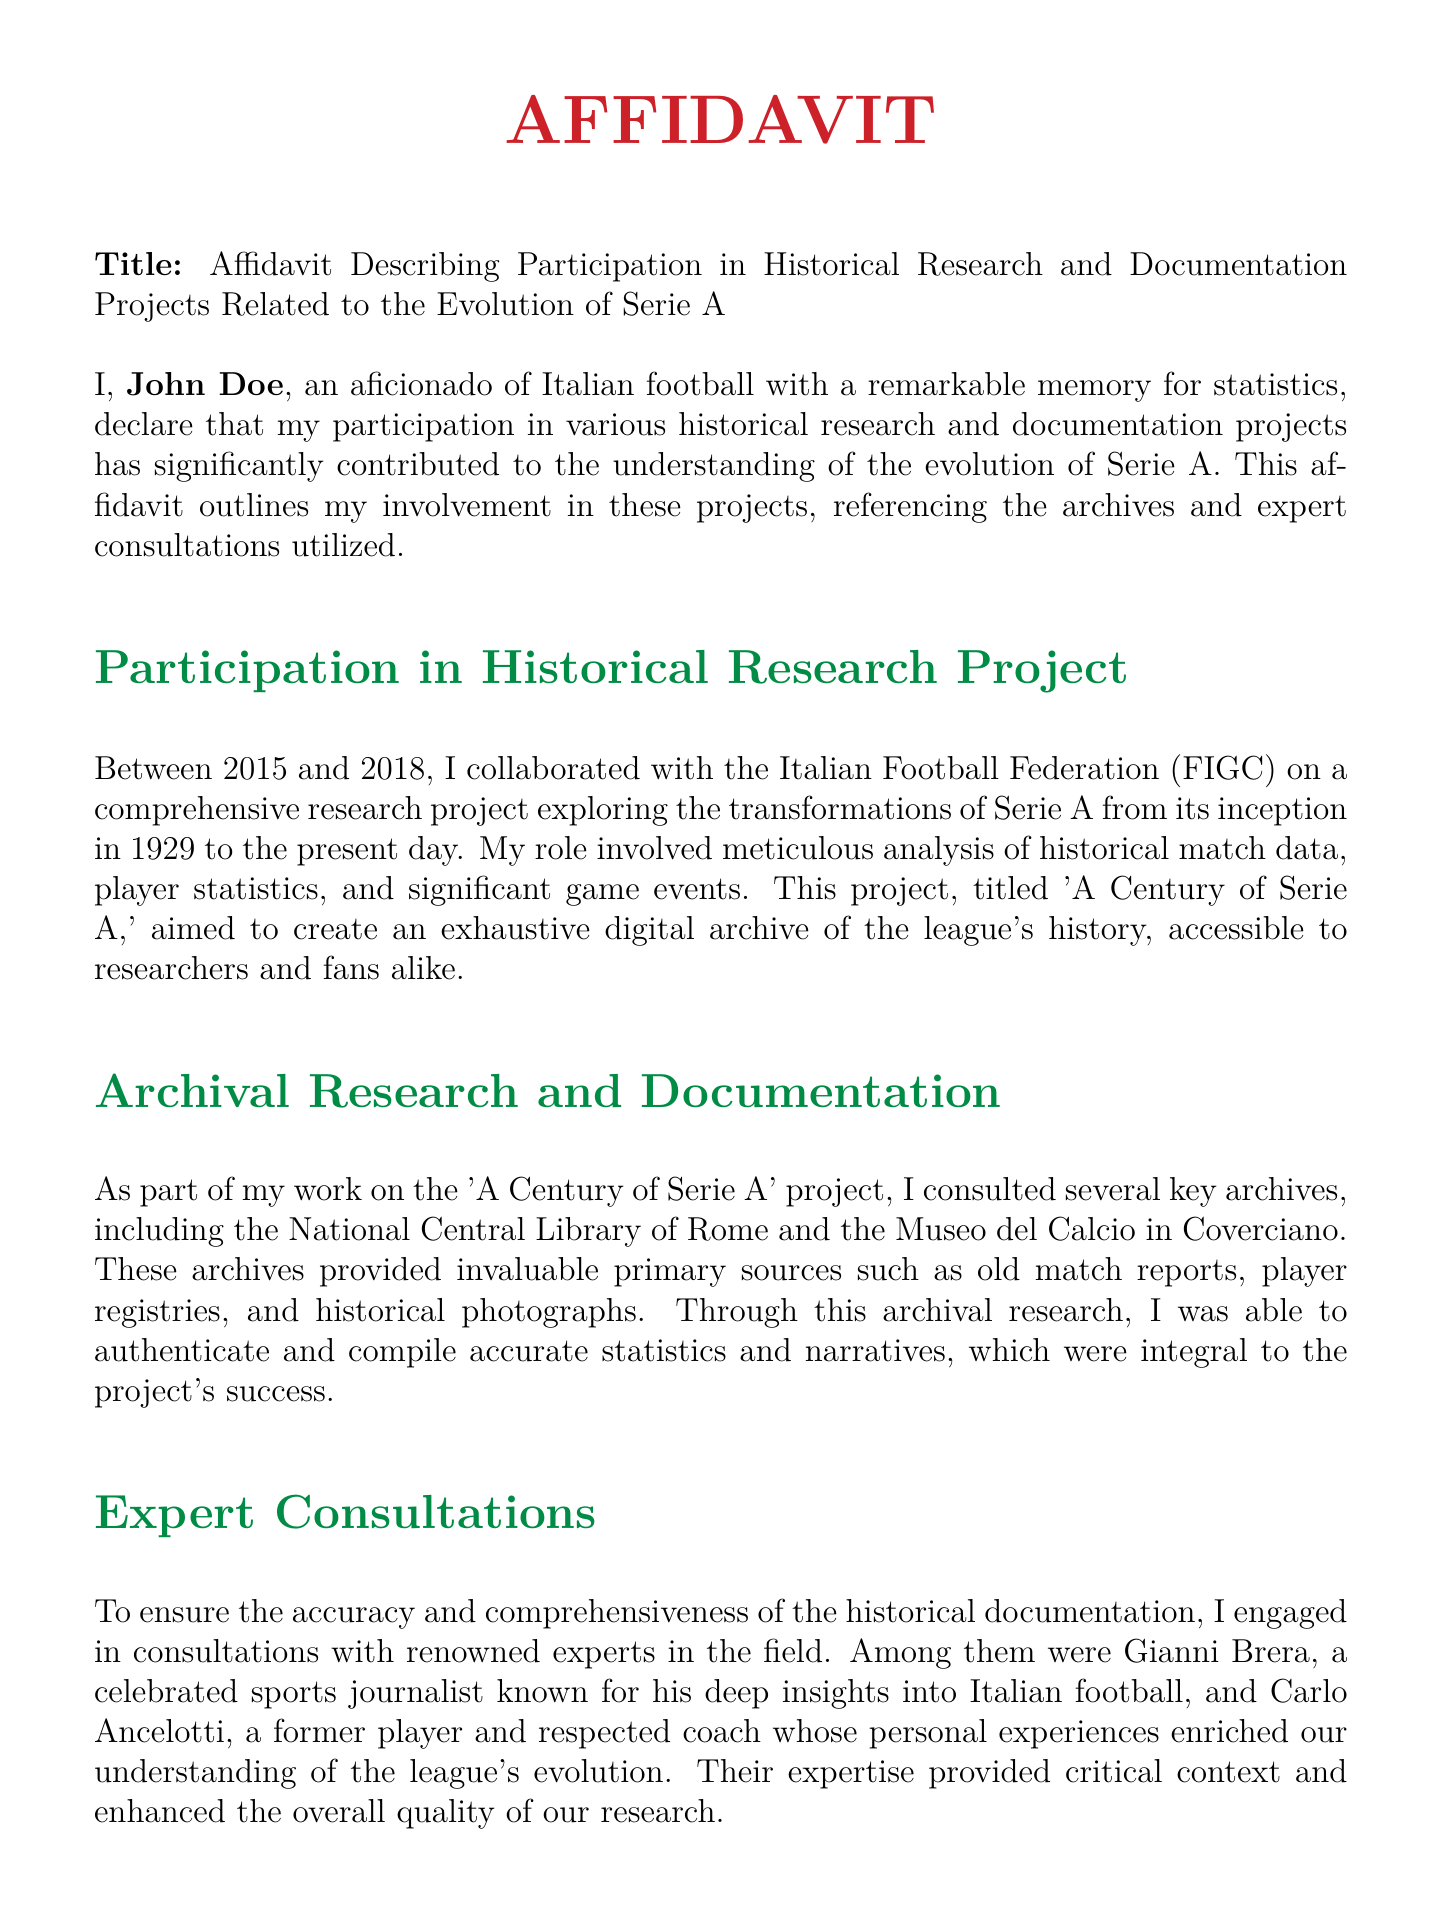What is the title of the affidavit? The title is mentioned at the beginning of the document, stating it is an affidavit describing participation in historical research and documentation projects related to Serie A.
Answer: Affidavit Describing Participation in Historical Research and Documentation Projects Related to the Evolution of Serie A Who is the declarant of the affidavit? The declarant's name is stated at the beginning of the document.
Answer: John Doe Between which years did the research project take place? The years of participation in the research project are specified in the document.
Answer: 2015 and 2018 What was the research project titled? The title of the research project is referenced within the document, detailing its focus on Serie A's history.
Answer: A Century of Serie A Name one of the key archives consulted in the research. The document lists several archives consulted during the research.
Answer: National Central Library of Rome Who was one of the experts consulted for the project? The document names experts who contributed to the project, highlighting their relevance.
Answer: Gianni Brera What type of resources were used from the archives? The affidavit mentions specific types of primary sources that contributed to the research.
Answer: Old match reports What was the main goal of the research project? The goal of the project is described in the affidavit, indicating its significance in historical documentation.
Answer: Create an exhaustive digital archive of the league's history What does the declarant affirm about the contents of the affidavit? The declarant's affirmation about the truthfulness of the affidavit is explicitly stated.
Answer: True to the best of my knowledge and belief 